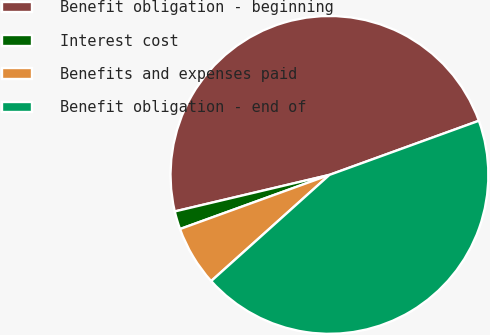<chart> <loc_0><loc_0><loc_500><loc_500><pie_chart><fcel>Benefit obligation - beginning<fcel>Interest cost<fcel>Benefits and expenses paid<fcel>Benefit obligation - end of<nl><fcel>48.16%<fcel>1.84%<fcel>6.11%<fcel>43.89%<nl></chart> 